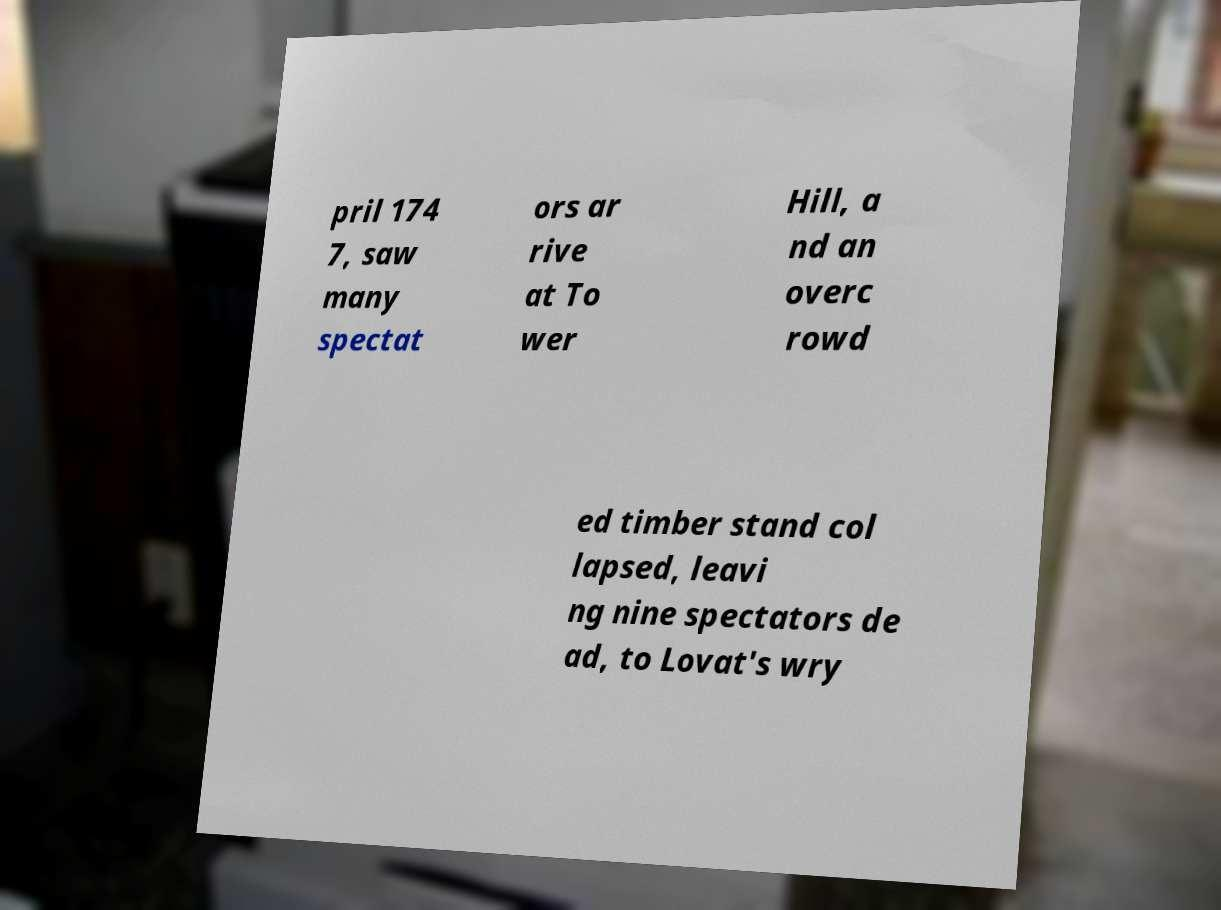For documentation purposes, I need the text within this image transcribed. Could you provide that? pril 174 7, saw many spectat ors ar rive at To wer Hill, a nd an overc rowd ed timber stand col lapsed, leavi ng nine spectators de ad, to Lovat's wry 